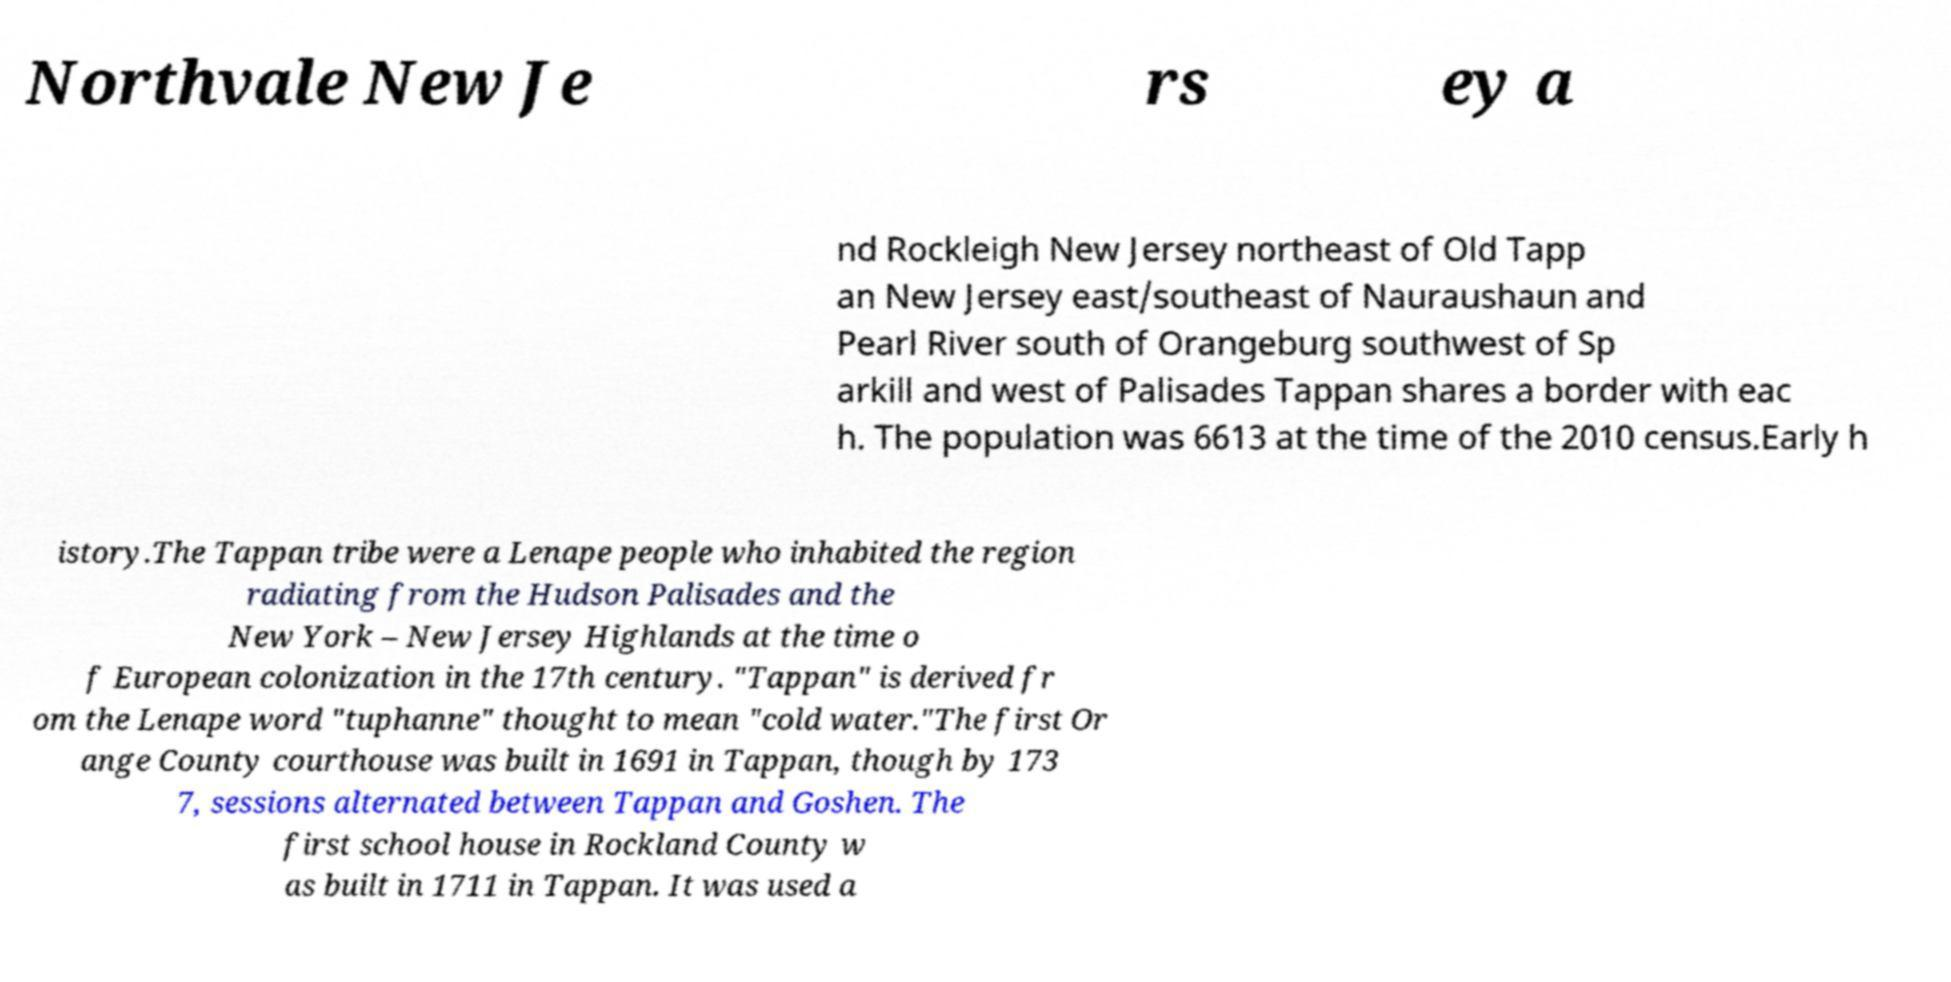Please identify and transcribe the text found in this image. Northvale New Je rs ey a nd Rockleigh New Jersey northeast of Old Tapp an New Jersey east/southeast of Nauraushaun and Pearl River south of Orangeburg southwest of Sp arkill and west of Palisades Tappan shares a border with eac h. The population was 6613 at the time of the 2010 census.Early h istory.The Tappan tribe were a Lenape people who inhabited the region radiating from the Hudson Palisades and the New York – New Jersey Highlands at the time o f European colonization in the 17th century. "Tappan" is derived fr om the Lenape word "tuphanne" thought to mean "cold water."The first Or ange County courthouse was built in 1691 in Tappan, though by 173 7, sessions alternated between Tappan and Goshen. The first school house in Rockland County w as built in 1711 in Tappan. It was used a 